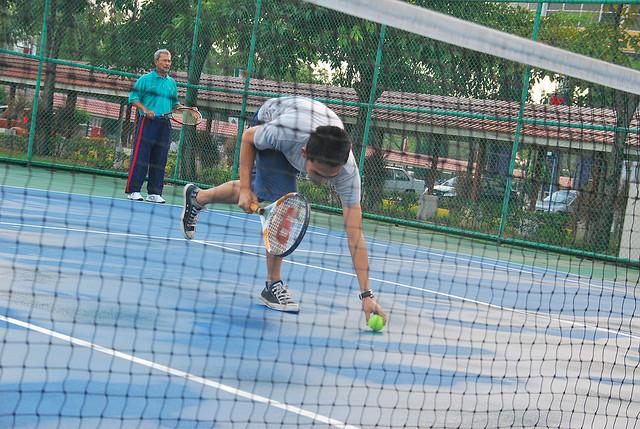Which company makes the green object here?

Choices:
A) wilson
B) coleco
C) kenner
D) timberland wilson 